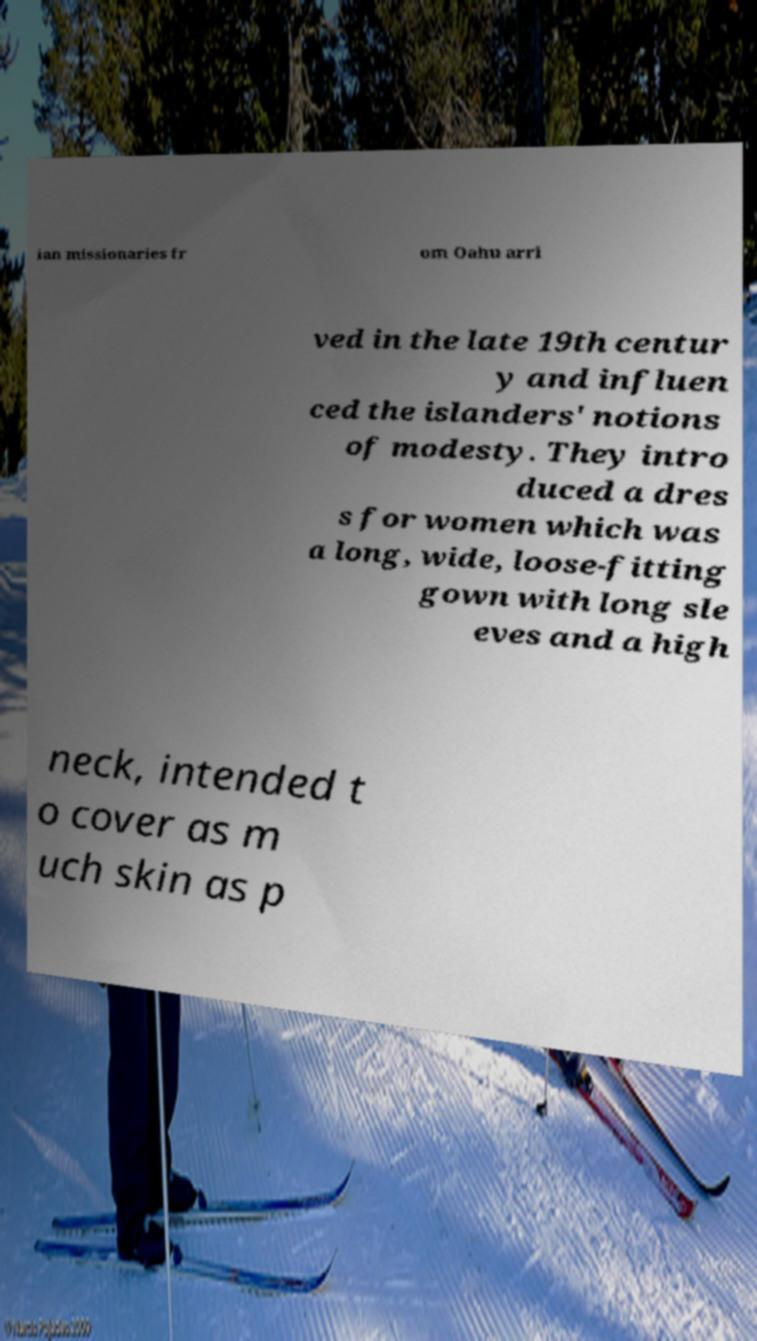There's text embedded in this image that I need extracted. Can you transcribe it verbatim? ian missionaries fr om Oahu arri ved in the late 19th centur y and influen ced the islanders' notions of modesty. They intro duced a dres s for women which was a long, wide, loose-fitting gown with long sle eves and a high neck, intended t o cover as m uch skin as p 